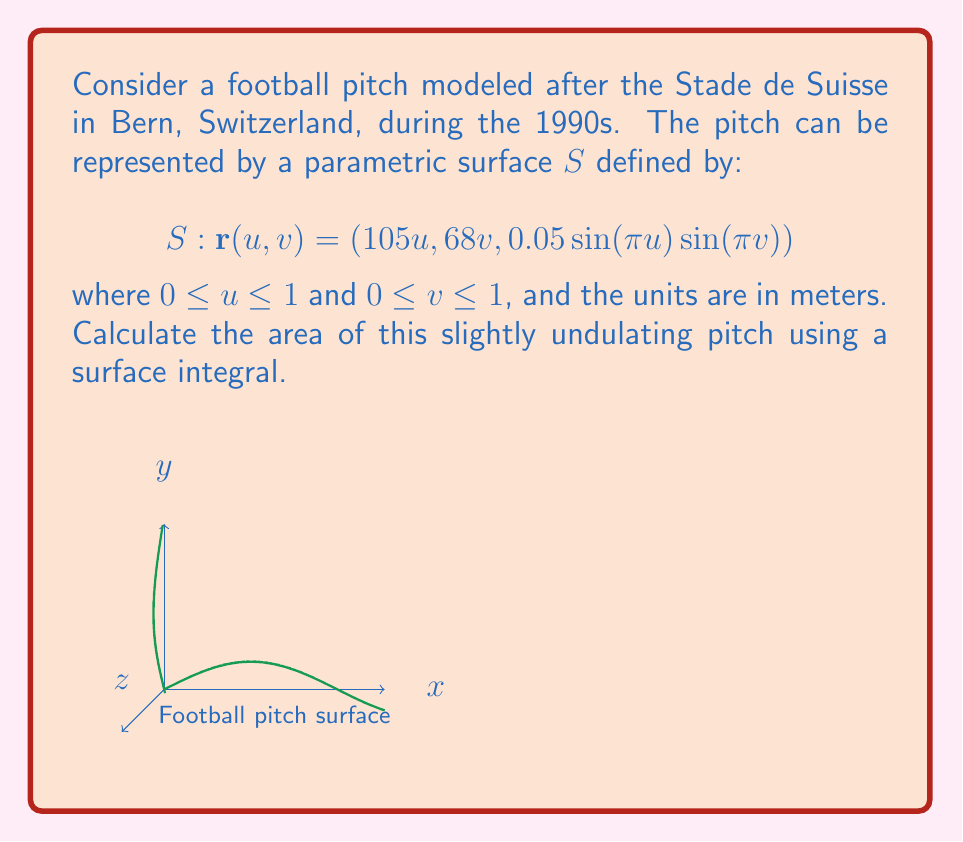Teach me how to tackle this problem. To find the area of the football pitch using a surface integral, we need to follow these steps:

1) The formula for the area of a parametric surface is:

   $$A = \iint_D \left|\frac{\partial \mathbf{r}}{\partial u} \times \frac{\partial \mathbf{r}}{\partial v}\right| du dv$$

2) Calculate the partial derivatives:
   $$\frac{\partial \mathbf{r}}{\partial u} = (105, 0, 0.05\pi\cos(\pi u)\sin(\pi v))$$
   $$\frac{\partial \mathbf{r}}{\partial v} = (0, 68, 0.05\pi\sin(\pi u)\cos(\pi v))$$

3) Calculate the cross product:
   $$\frac{\partial \mathbf{r}}{\partial u} \times \frac{\partial \mathbf{r}}{\partial v} = (7140\pi\sin(\pi u)\cos(\pi v), -5250\pi\cos(\pi u)\sin(\pi v), 7140)$$

4) Calculate the magnitude of the cross product:
   $$\left|\frac{\partial \mathbf{r}}{\partial u} \times \frac{\partial \mathbf{r}}{\partial v}\right| = \sqrt{(7140\pi\sin(\pi u)\cos(\pi v))^2 + (-5250\pi\cos(\pi u)\sin(\pi v))^2 + 7140^2}$$

5) Simplify:
   $$\left|\frac{\partial \mathbf{r}}{\partial u} \times \frac{\partial \mathbf{r}}{\partial v}\right| = \sqrt{7140^2(1 + \pi^2(\sin^2(\pi u)\cos^2(\pi v) + \cos^2(\pi u)\sin^2(\pi v)))}$$

6) Set up the double integral:
   $$A = \int_0^1 \int_0^1 \sqrt{7140^2(1 + \pi^2(\sin^2(\pi u)\cos^2(\pi v) + \cos^2(\pi u)\sin^2(\pi v)))} du dv$$

7) This integral is difficult to evaluate analytically. We can approximate it numerically or observe that the term under the square root is very close to 7140^2 because the sine and cosine terms are small. Therefore, we can approximate:

   $$A \approx \int_0^1 \int_0^1 7140 du dv = 7140$$

This approximation gives us the area of the flat pitch, which is very close to the actual area of the slightly undulating pitch.
Answer: $7140 \text{ m}^2$ (approximately) 